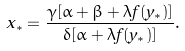<formula> <loc_0><loc_0><loc_500><loc_500>x _ { * } = \frac { \gamma [ \alpha + \beta + \lambda f ( y _ { * } ) ] } { \delta [ \alpha + \lambda f ( y _ { * } ) ] } .</formula> 